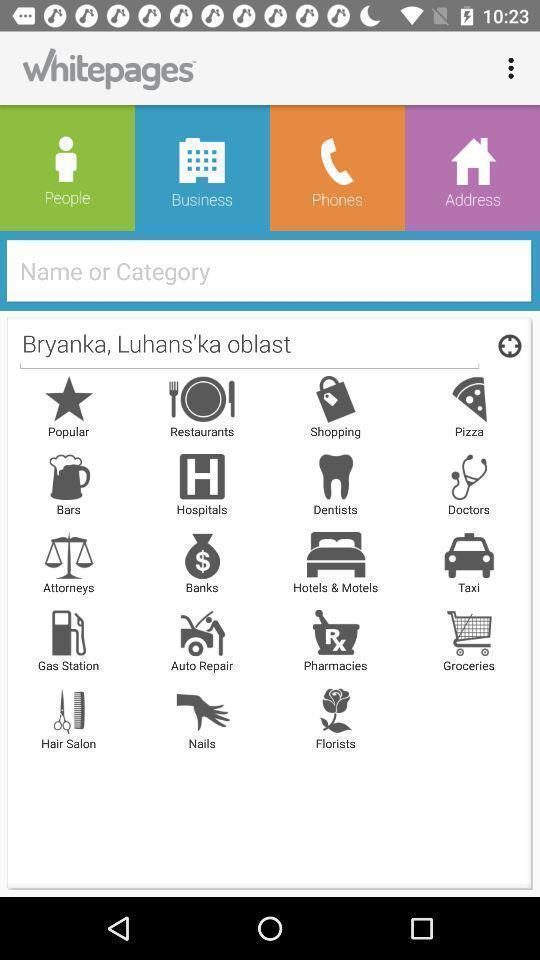Provide a description of this screenshot. Search bar and options in a people search app. 